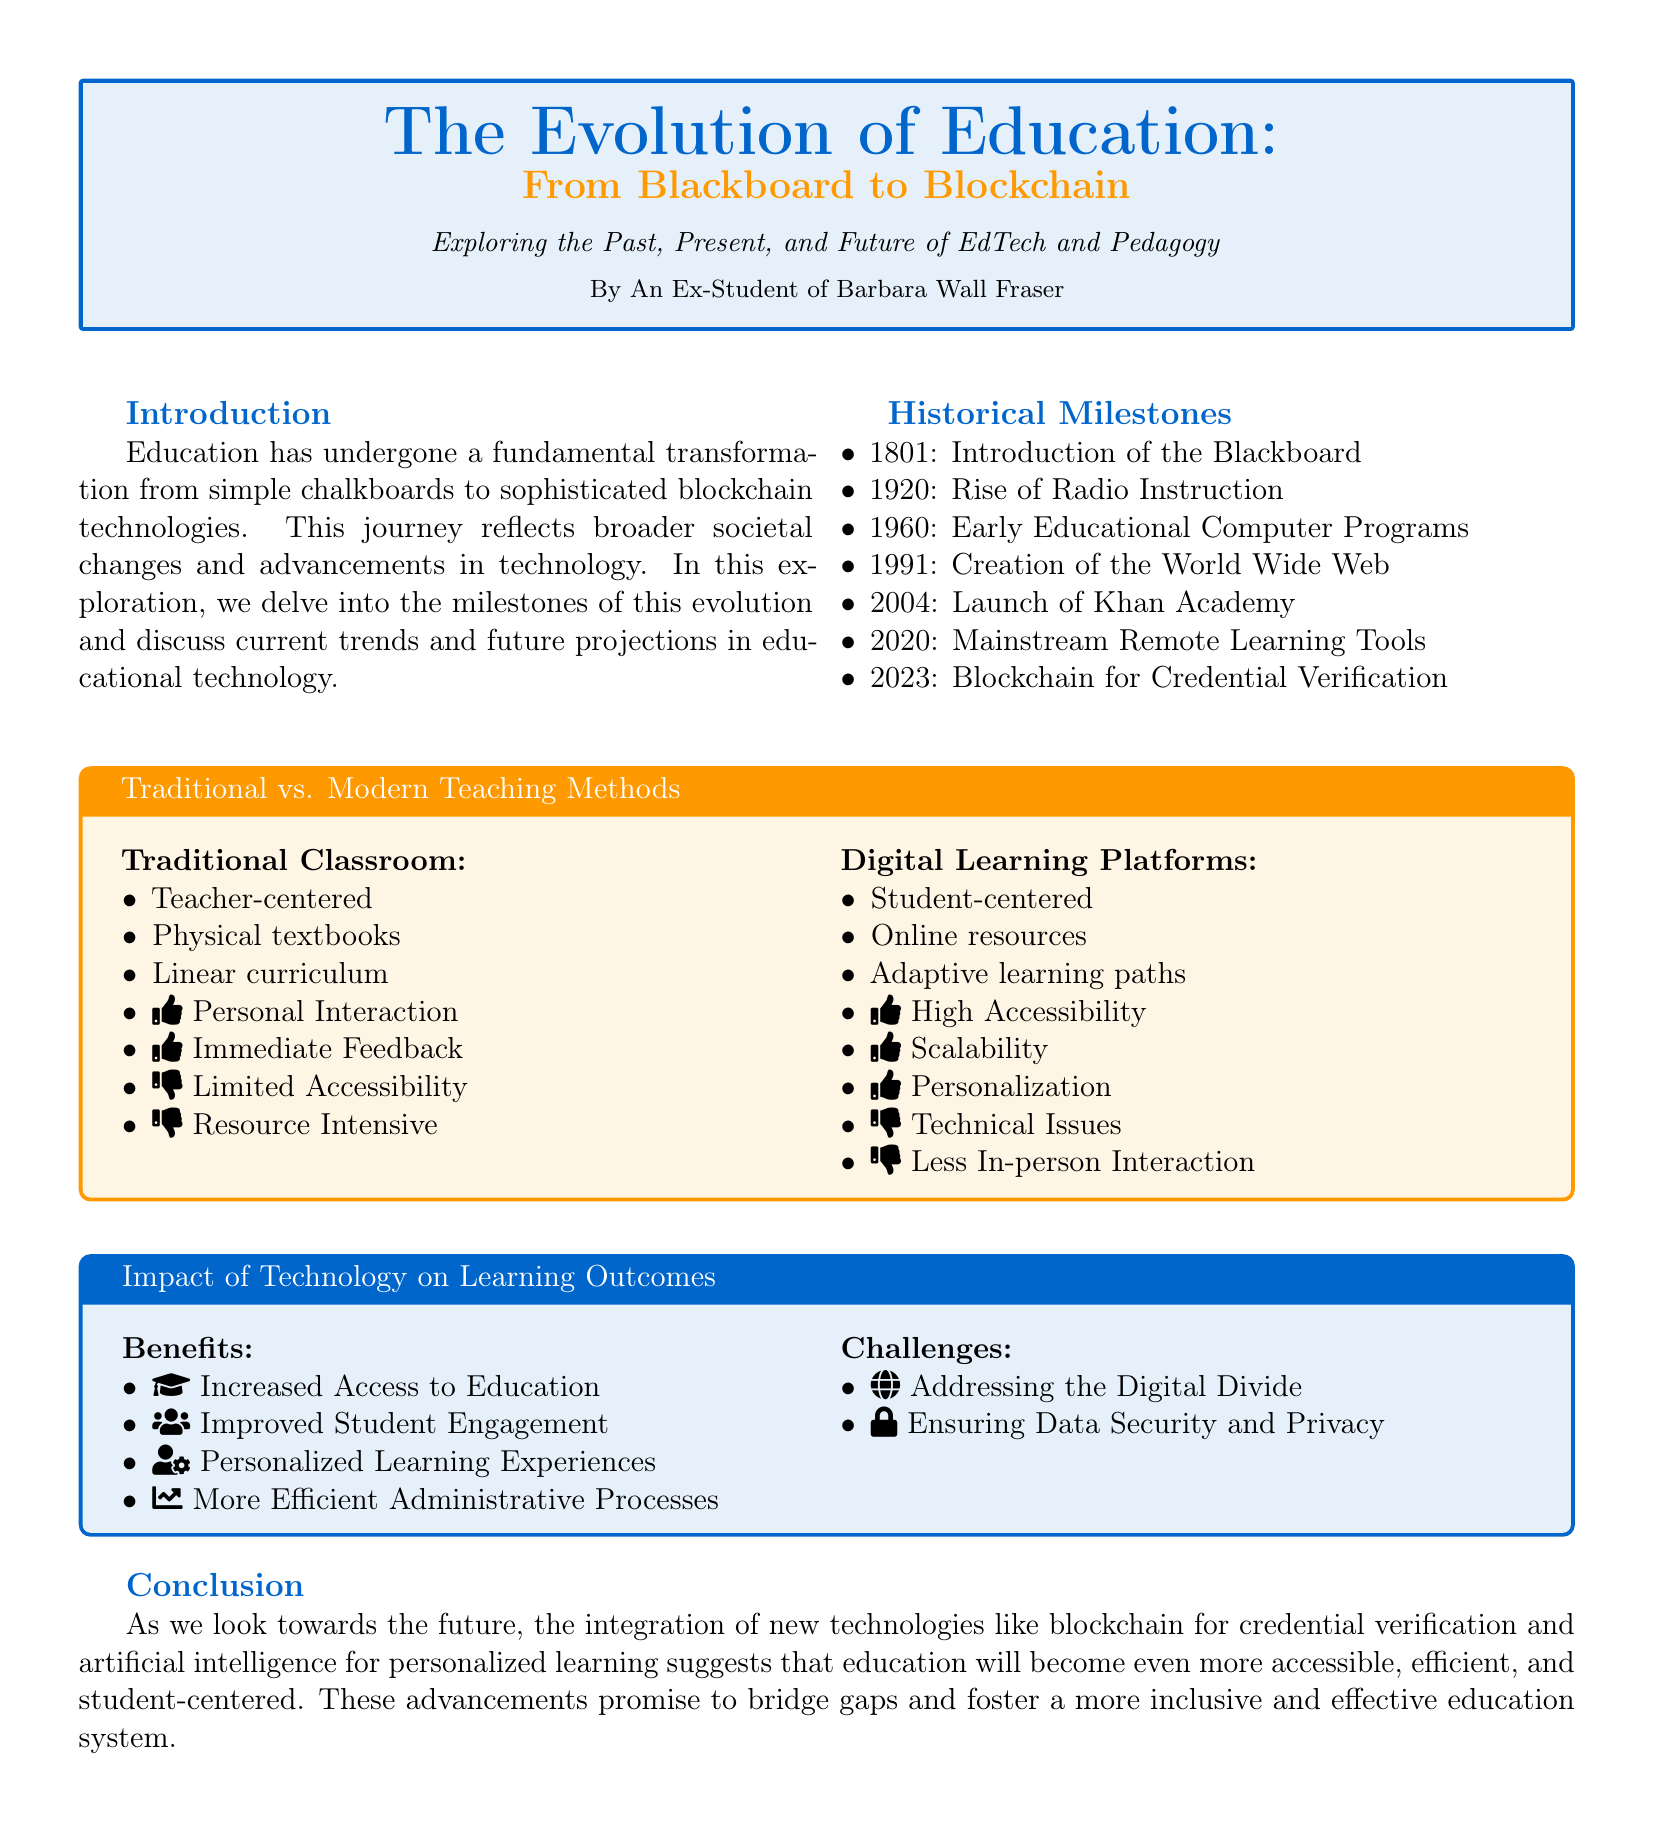What year was the Blackboard introduced? The document provides a historical milestone list where the introduction of the Blackboard is dated 1801.
Answer: 1801 What is one benefit of technology in learning outcomes? The document lists benefits of technology, one of which includes increased access to education.
Answer: Increased Access to Education What is the primary focus of traditional classrooms? The traditional classroom's focus is described as teacher-centered in the document.
Answer: Teacher-centered Name one challenge mentioned related to technology. The document outlines challenges, including addressing the digital divide.
Answer: Addressing the Digital Divide What major educational platform was launched in 2004? The historical milestone section lists Khan Academy as launched in 2004.
Answer: Khan Academy What type of learning paths do digital platforms offer? The document states that digital learning platforms provide adaptive learning paths.
Answer: Adaptive learning paths What year did blockchain begin being used for credential verification? The document mentions that blockchain for credential verification was introduced in 2023.
Answer: 2023 What design element is used to compare teaching methods? The document features a comparative chart to illustrate differences between traditional and modern teaching methods.
Answer: Comparative chart What is one key attribute of digital learning platforms? The document highlights personalization as a key attribute of digital learning platforms.
Answer: Personalization 